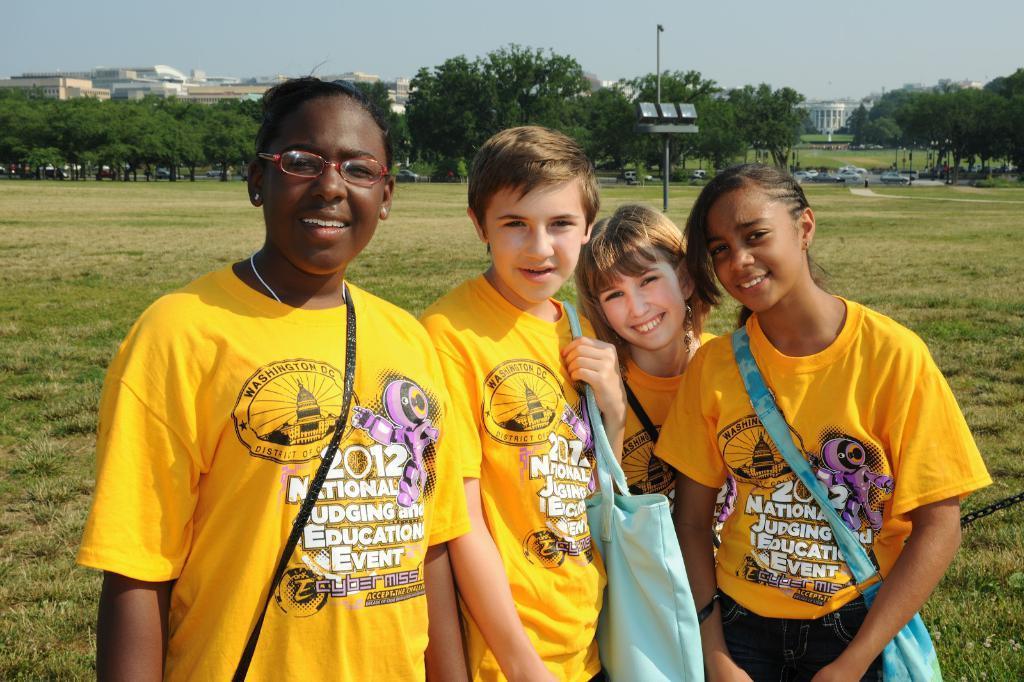Could you give a brief overview of what you see in this image? In front of the picture, we see three girls and a boy are standing. They are wearing the bags and all of them are wearing the yellow T-shirts. All of them are smiling and they are posing for the photo. At the bottom, we see the grass. In the middle, we see a pole. There are trees, buildings and the cars in the background. At the top, we see the sky. 